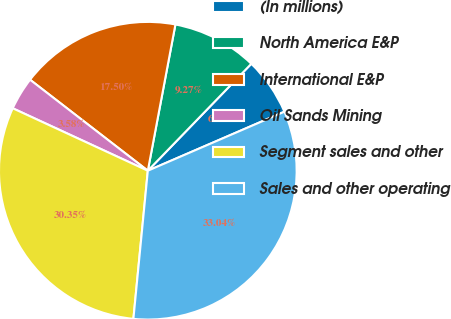<chart> <loc_0><loc_0><loc_500><loc_500><pie_chart><fcel>(In millions)<fcel>North America E&P<fcel>International E&P<fcel>Oil Sands Mining<fcel>Segment sales and other<fcel>Sales and other operating<nl><fcel>6.27%<fcel>9.27%<fcel>17.5%<fcel>3.58%<fcel>30.35%<fcel>33.04%<nl></chart> 